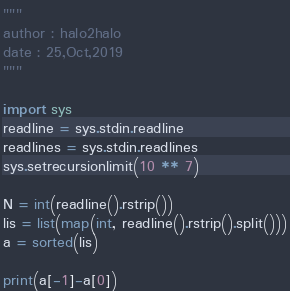<code> <loc_0><loc_0><loc_500><loc_500><_Python_>"""
author : halo2halo
date : 25,Oct,2019
"""

import sys
readline = sys.stdin.readline
readlines = sys.stdin.readlines
sys.setrecursionlimit(10 ** 7)

N = int(readline().rstrip())
lis = list(map(int, readline().rstrip().split()))
a = sorted(lis)

print(a[-1]-a[0])
</code> 